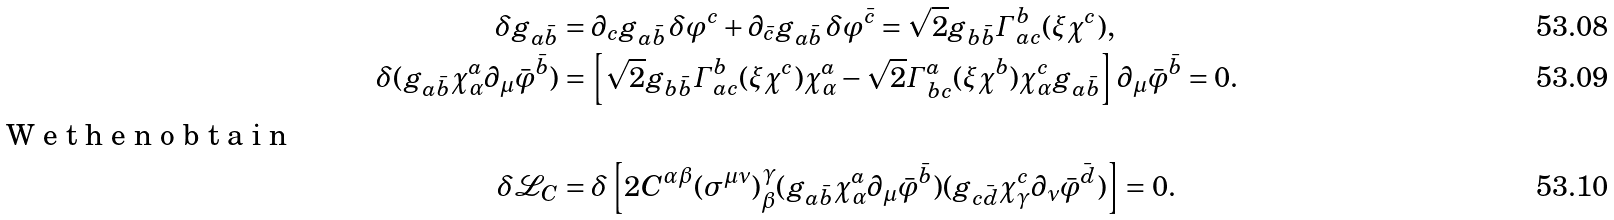Convert formula to latex. <formula><loc_0><loc_0><loc_500><loc_500>\delta g _ { a \bar { b } } & = \partial _ { c } g _ { a \bar { b } } \, \delta \varphi ^ { c } + \partial _ { \bar { c } } g _ { a \bar { b } } \, \delta \varphi ^ { \bar { c } } = \sqrt { 2 } g _ { b \bar { b } } \varGamma ^ { b } _ { a c } ( \xi \chi ^ { c } ) , \\ \delta ( g _ { a \bar { b } } \chi ^ { a } _ { \alpha } \partial _ { \mu } \bar { \varphi } ^ { \bar { b } } ) & = \left [ \sqrt { 2 } g _ { b \bar { b } } \varGamma ^ { b } _ { a c } ( \xi \chi ^ { c } ) \chi ^ { a } _ { \alpha } - \sqrt { 2 } \varGamma ^ { a } _ { b c } ( \xi \chi ^ { b } ) \chi ^ { c } _ { \alpha } g _ { a \bar { b } } \right ] \partial _ { \mu } \bar { \varphi } ^ { \bar { b } } = 0 . \\ \intertext { W e t h e n o b t a i n } \delta \mathcal { L } _ { C } & = \delta \left [ 2 C ^ { \alpha \beta } ( \sigma ^ { \mu \nu } ) _ { \beta } ^ { \, \gamma } ( g _ { a \bar { b } } \chi ^ { a } _ { \alpha } \partial _ { \mu } \bar { \varphi } ^ { \bar { b } } ) ( g _ { c \bar { d } } \chi ^ { c } _ { \gamma } \partial _ { \nu } \bar { \varphi } ^ { \bar { d } } ) \right ] = 0 .</formula> 